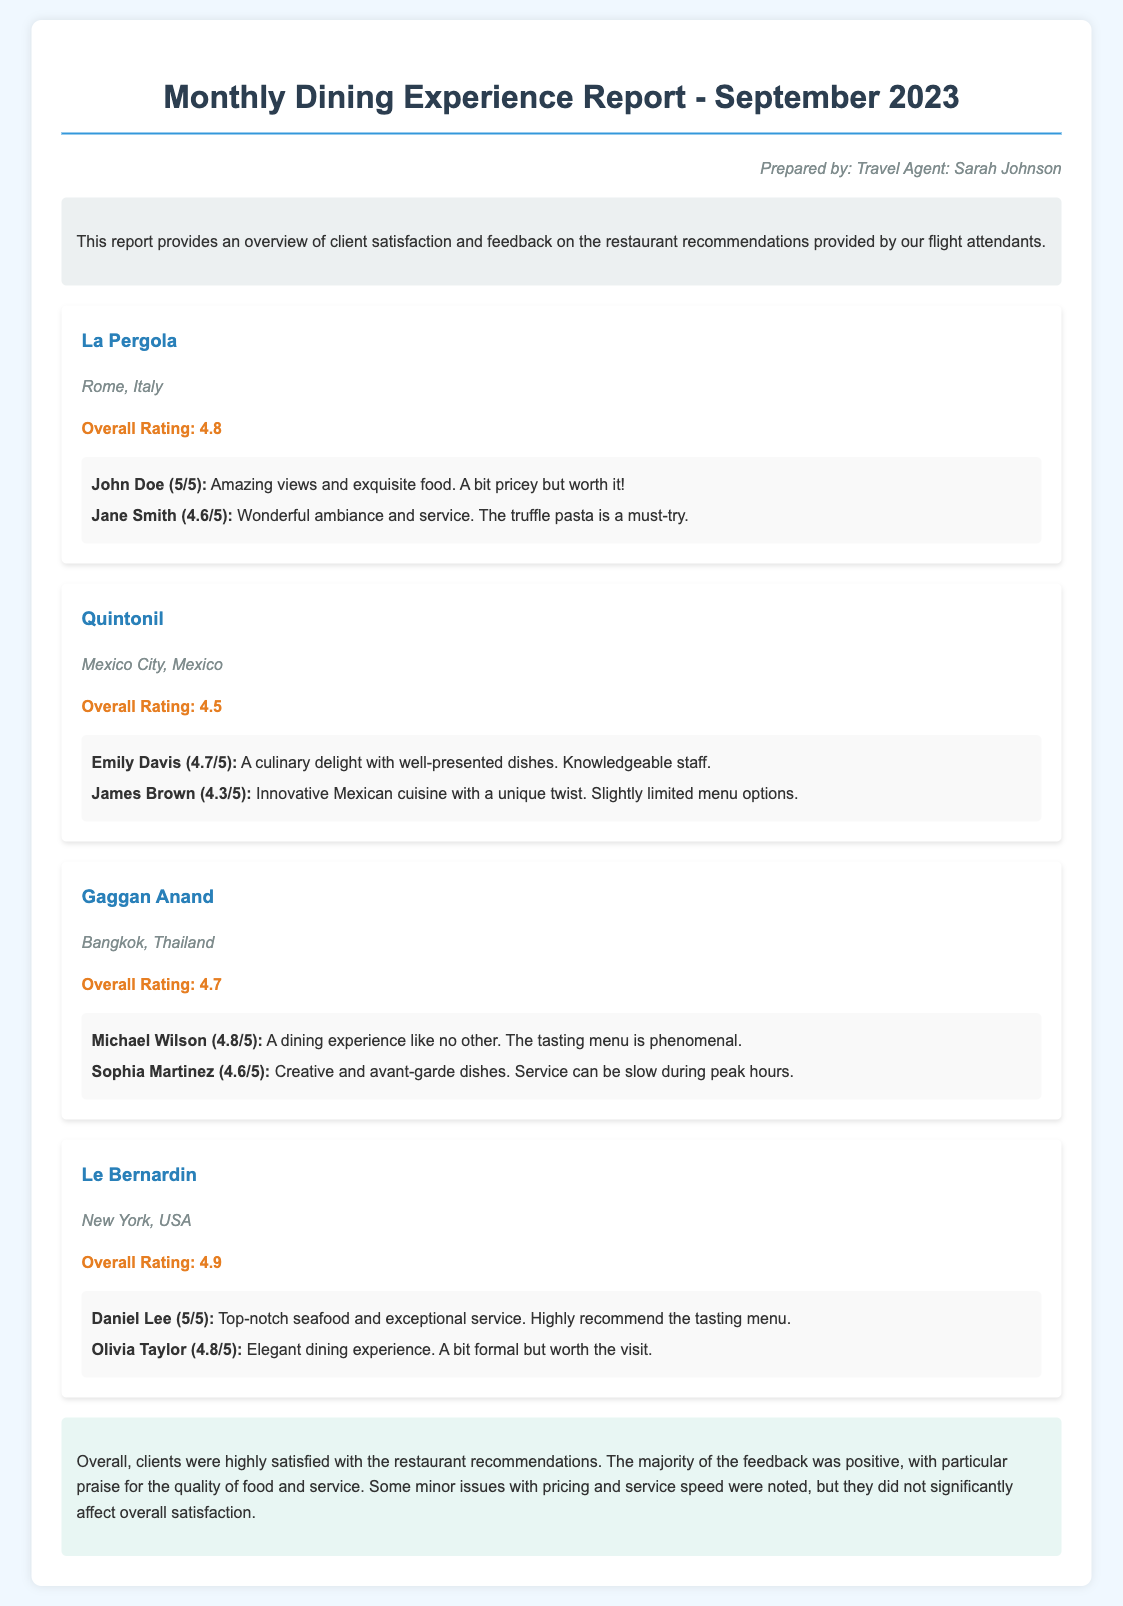What is the overall rating for La Pergola? The overall rating for La Pergola is 4.8, as noted in the document.
Answer: 4.8 Who is the prepared by individual listed in the report? The prepared by individual listed in the report is Travel Agent: Sarah Johnson.
Answer: Sarah Johnson Which restaurant has the highest overall rating? The restaurant with the highest overall rating is Le Bernardin with a rating of 4.9.
Answer: Le Bernardin What feedback did John Doe give for La Pergola? John Doe's feedback for La Pergola was that it has amazing views and exquisite food, giving it a rating of 5/5.
Answer: Amazing views and exquisite food Are there any comments about the service speed at Gaggan Anand? Yes, the feedback noted that service can be slow during peak hours at Gaggan Anand.
Answer: Service can be slow during peak hours Overall, what was the clients’ satisfaction with the restaurant recommendations? The document states that clients were highly satisfied with the restaurant recommendations.
Answer: Highly satisfied What cuisine is featured at Quintonil? Quintonil features innovative Mexican cuisine as identified in the document.
Answer: Innovative Mexican cuisine Which city is Gaggan Anand located in? Gaggan Anand is located in Bangkok, Thailand, according to the document.
Answer: Bangkok, Thailand 